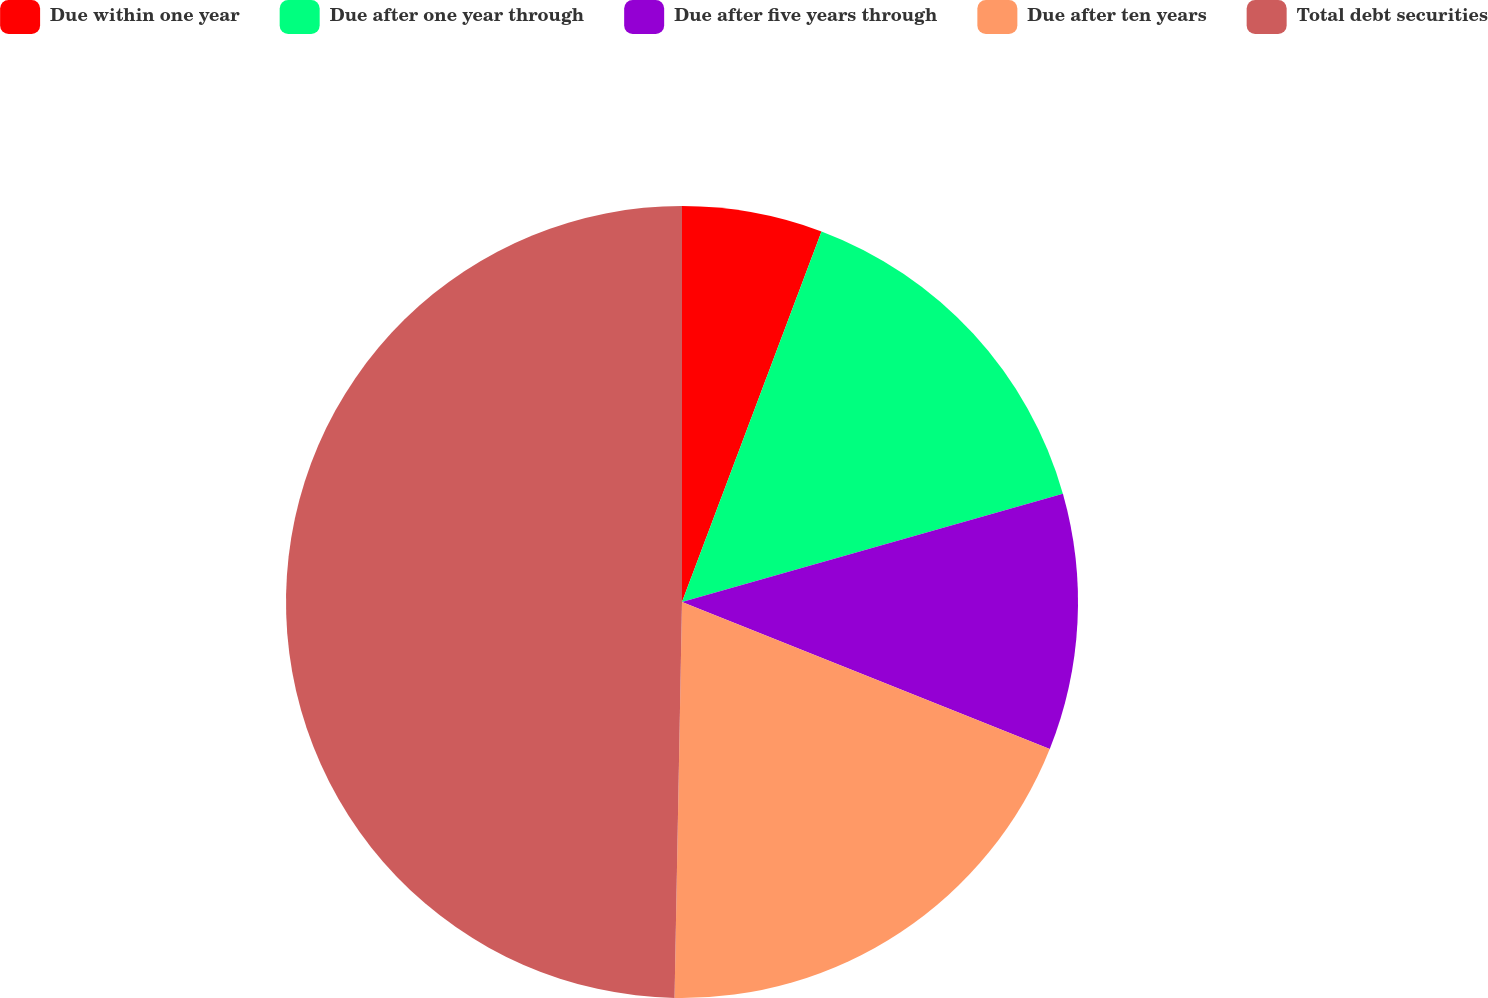<chart> <loc_0><loc_0><loc_500><loc_500><pie_chart><fcel>Due within one year<fcel>Due after one year through<fcel>Due after five years through<fcel>Due after ten years<fcel>Total debt securities<nl><fcel>5.73%<fcel>14.86%<fcel>10.46%<fcel>19.25%<fcel>49.7%<nl></chart> 